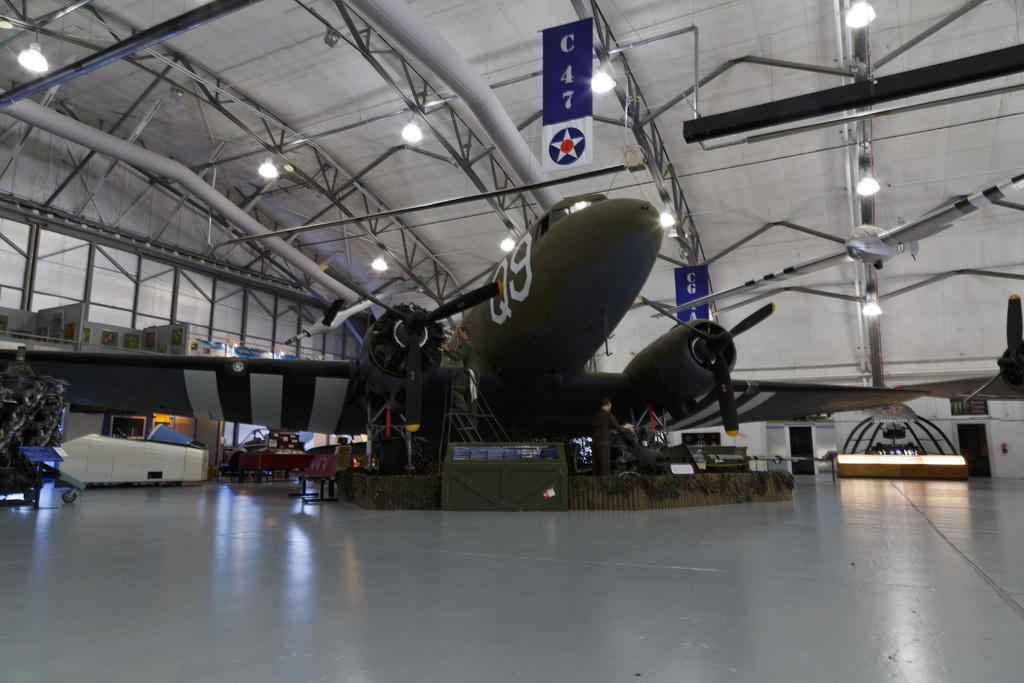<image>
Describe the image concisely. A war plane labeled Q9 and painted in green is on a display inside a hangar. 